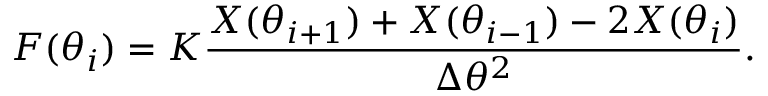<formula> <loc_0><loc_0><loc_500><loc_500>\boldsymbol F ( \theta _ { i } ) = K \frac { \boldsymbol X ( \theta _ { i + 1 } ) + \boldsymbol X ( \theta _ { i - 1 } ) - 2 \boldsymbol X ( \theta _ { i } ) } { \Delta \theta ^ { 2 } } .</formula> 